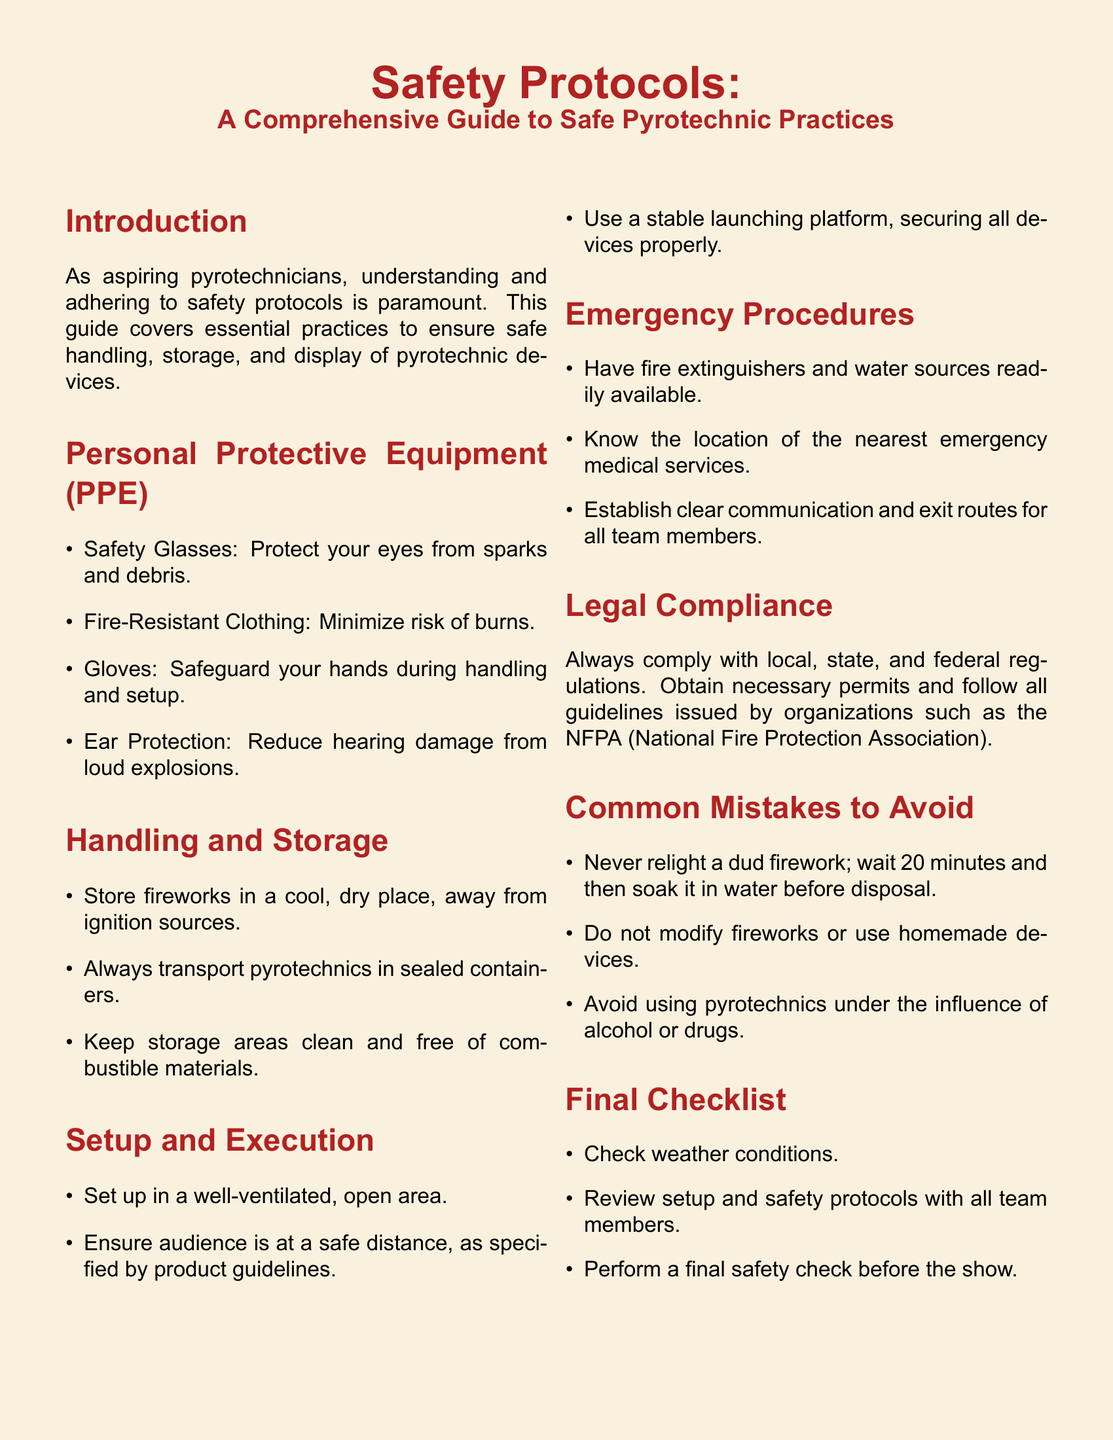what should be worn to protect the eyes? The document specifies safety glasses as the protection for the eyes during pyrotechnic activities.
Answer: safety glasses where should fireworks be stored? The guide indicates that fireworks should be stored in a cool, dry place, away from ignition sources.
Answer: cool, dry place what should be readily available during an emergency? According to the emergency procedures section, fire extinguishers and water sources should be readily available.
Answer: fire extinguishers what is a common mistake to avoid when handling fireworks? The document highlights that one should never relight a dud firework.
Answer: never relight a dud firework how far should the audience be from the setup? The guide instructs to ensure the audience is at a safe distance as specified by product guidelines.
Answer: safe distance 